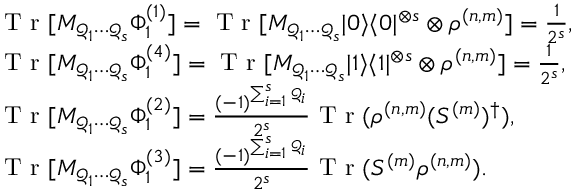<formula> <loc_0><loc_0><loc_500><loc_500>\begin{array} { r l } & { T r [ M _ { \mathcal { Q } _ { 1 } \cdots \mathcal { Q } _ { s } } \Phi _ { 1 } ^ { ( 1 ) } ] = T r [ M _ { \mathcal { Q } _ { 1 } \cdots \mathcal { Q } _ { s } } | 0 \rangle \langle 0 | ^ { \otimes s } \otimes \rho ^ { ( n , m ) } ] = \frac { 1 } { 2 ^ { s } } , } \\ & { T r [ M _ { \mathcal { Q } _ { 1 } \cdots \mathcal { Q } _ { s } } \Phi _ { 1 } ^ { ( 4 ) } ] = T r [ M _ { \mathcal { Q } _ { 1 } \cdots \mathcal { Q } _ { s } } | 1 \rangle \langle 1 | ^ { \otimes s } \otimes \rho ^ { ( n , m ) } ] = \frac { 1 } { 2 ^ { s } } , } \\ & { T r [ M _ { \mathcal { Q } _ { 1 } \cdots \mathcal { Q } _ { s } } \Phi _ { 1 } ^ { ( 2 ) } ] = \frac { ( - 1 ) ^ { \sum _ { i = 1 } ^ { s } \mathcal { Q } _ { i } } } { 2 ^ { s } } T r ( \rho ^ { ( n , m ) } ( S ^ { ( m ) } ) ^ { \dag } ) , } \\ & { T r [ M _ { \mathcal { Q } _ { 1 } \cdots \mathcal { Q } _ { s } } \Phi _ { 1 } ^ { ( 3 ) } ] = \frac { ( - 1 ) ^ { \sum _ { i = 1 } ^ { s } \mathcal { Q } _ { i } } } { 2 ^ { s } } T r ( S ^ { ( m ) } \rho ^ { ( n , m ) } ) . } \end{array}</formula> 